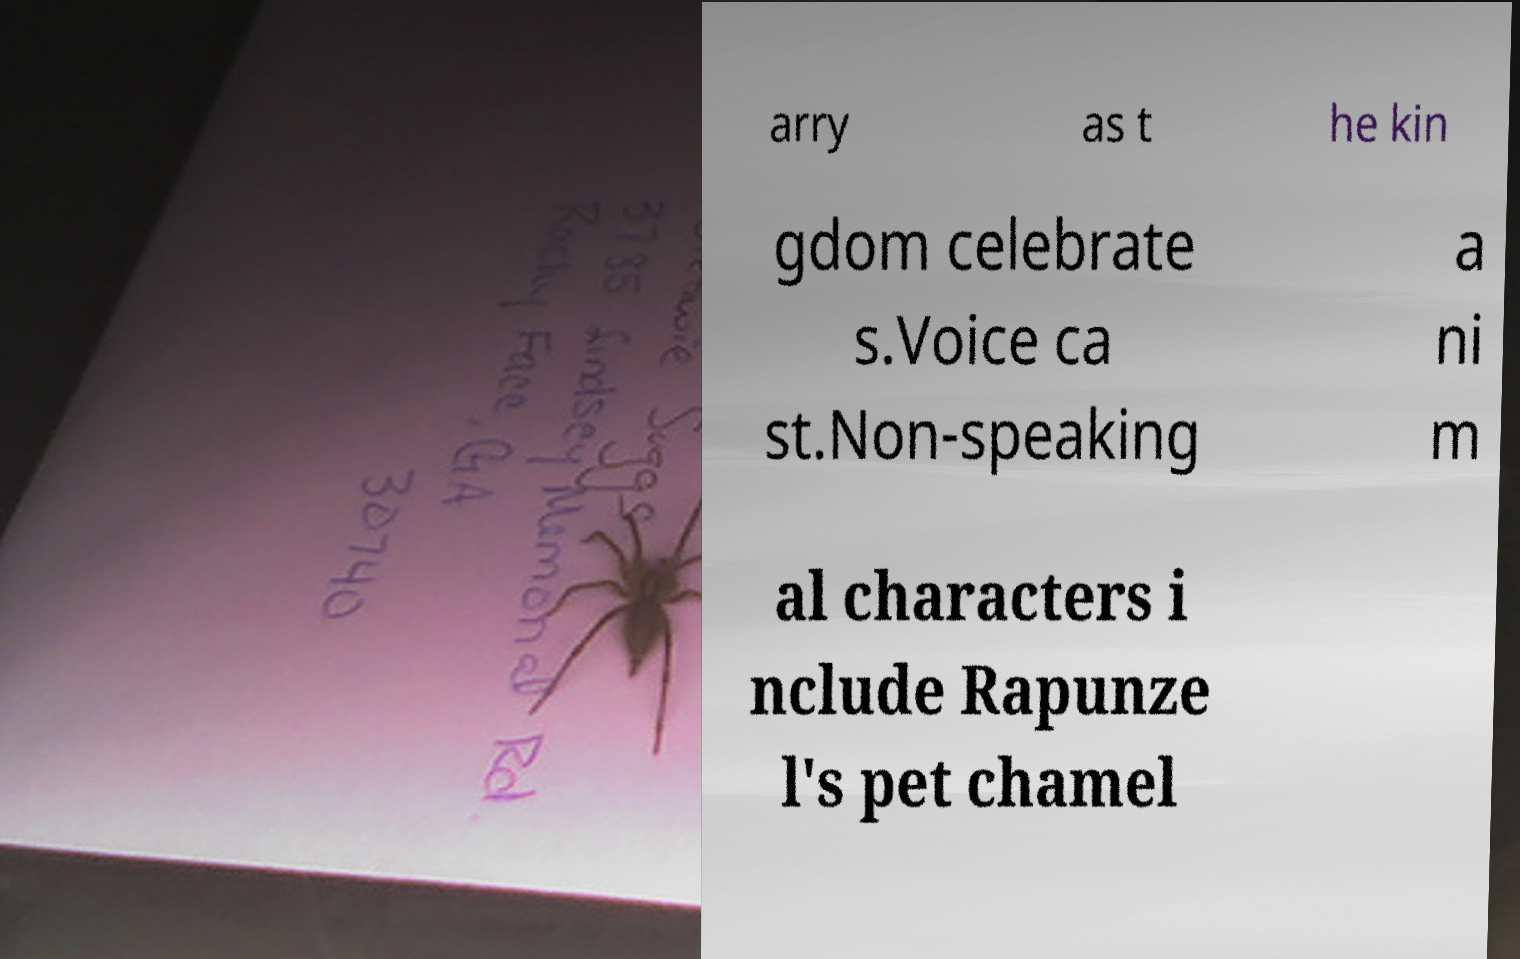What messages or text are displayed in this image? I need them in a readable, typed format. arry as t he kin gdom celebrate s.Voice ca st.Non-speaking a ni m al characters i nclude Rapunze l's pet chamel 